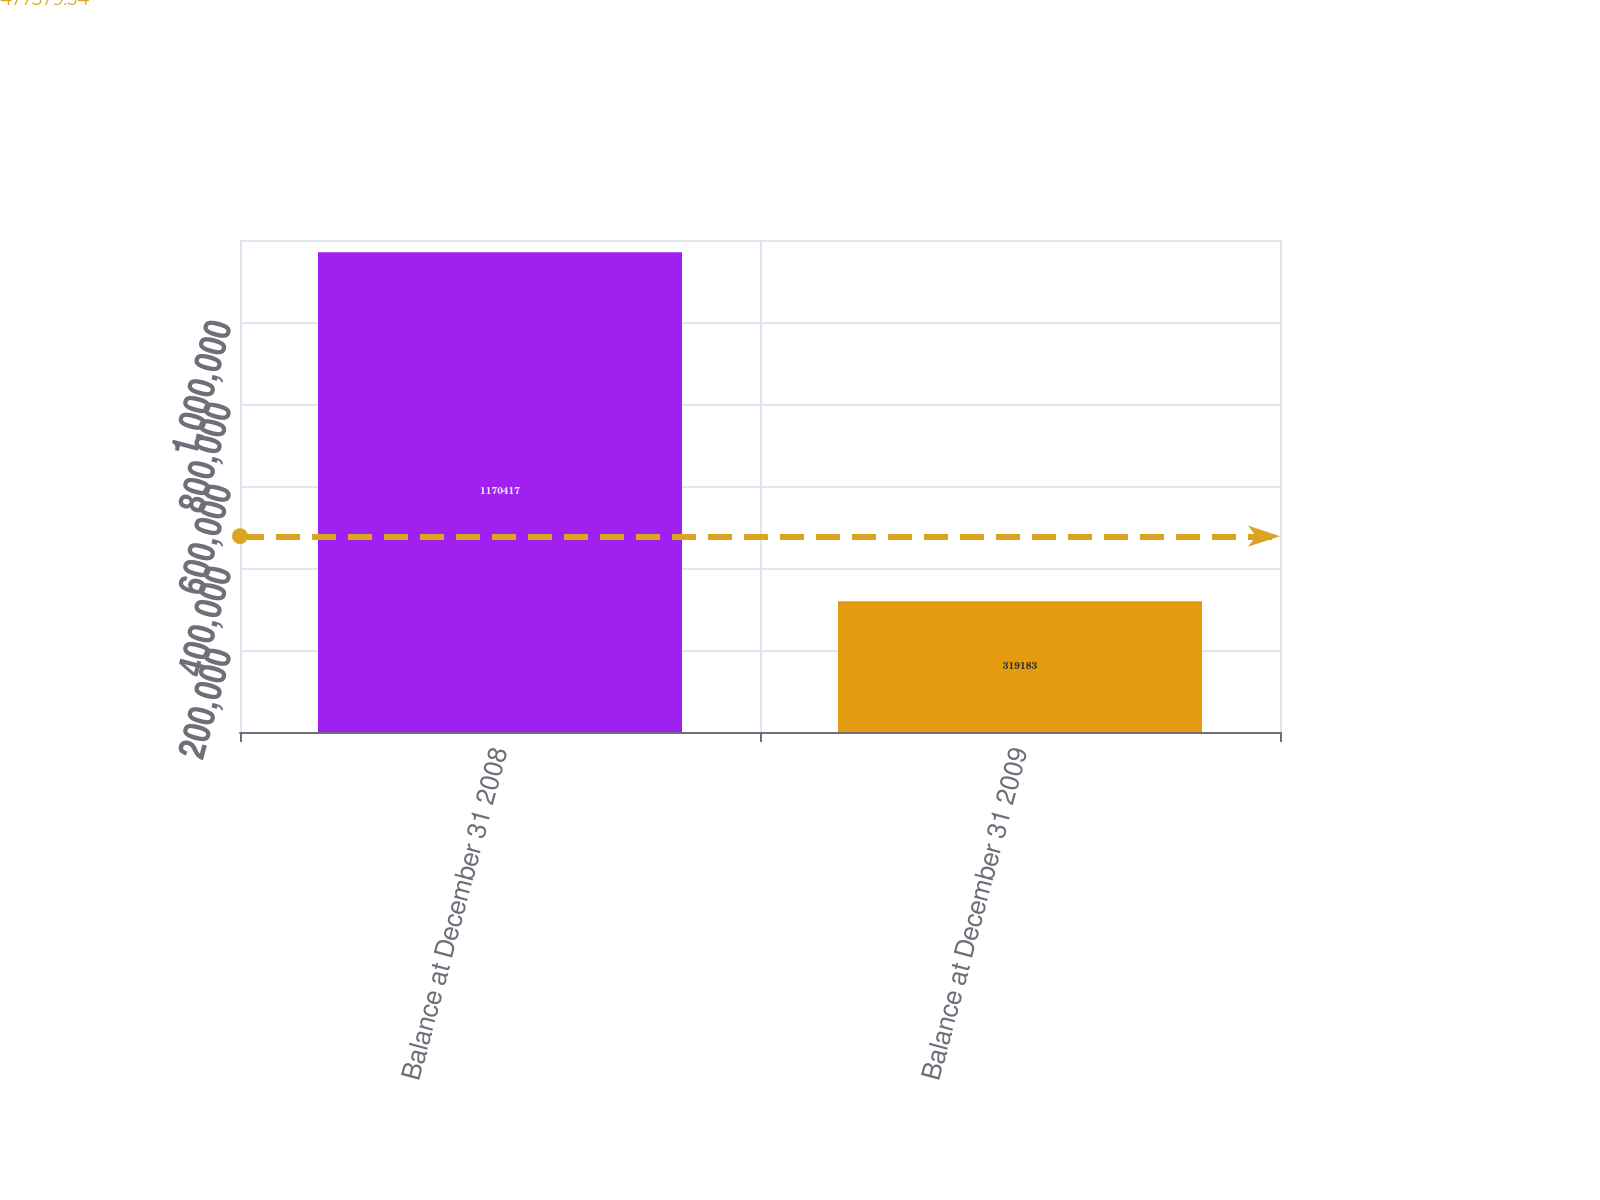<chart> <loc_0><loc_0><loc_500><loc_500><bar_chart><fcel>Balance at December 31 2008<fcel>Balance at December 31 2009<nl><fcel>1.17042e+06<fcel>319183<nl></chart> 